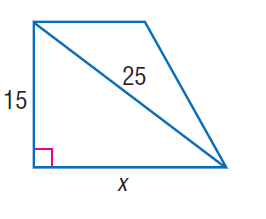Answer the mathemtical geometry problem and directly provide the correct option letter.
Question: Find x.
Choices: A: 10 B: 15 C: 20 D: 25 C 